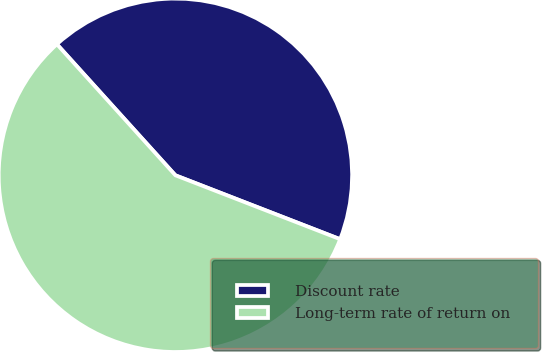<chart> <loc_0><loc_0><loc_500><loc_500><pie_chart><fcel>Discount rate<fcel>Long-term rate of return on<nl><fcel>42.59%<fcel>57.41%<nl></chart> 